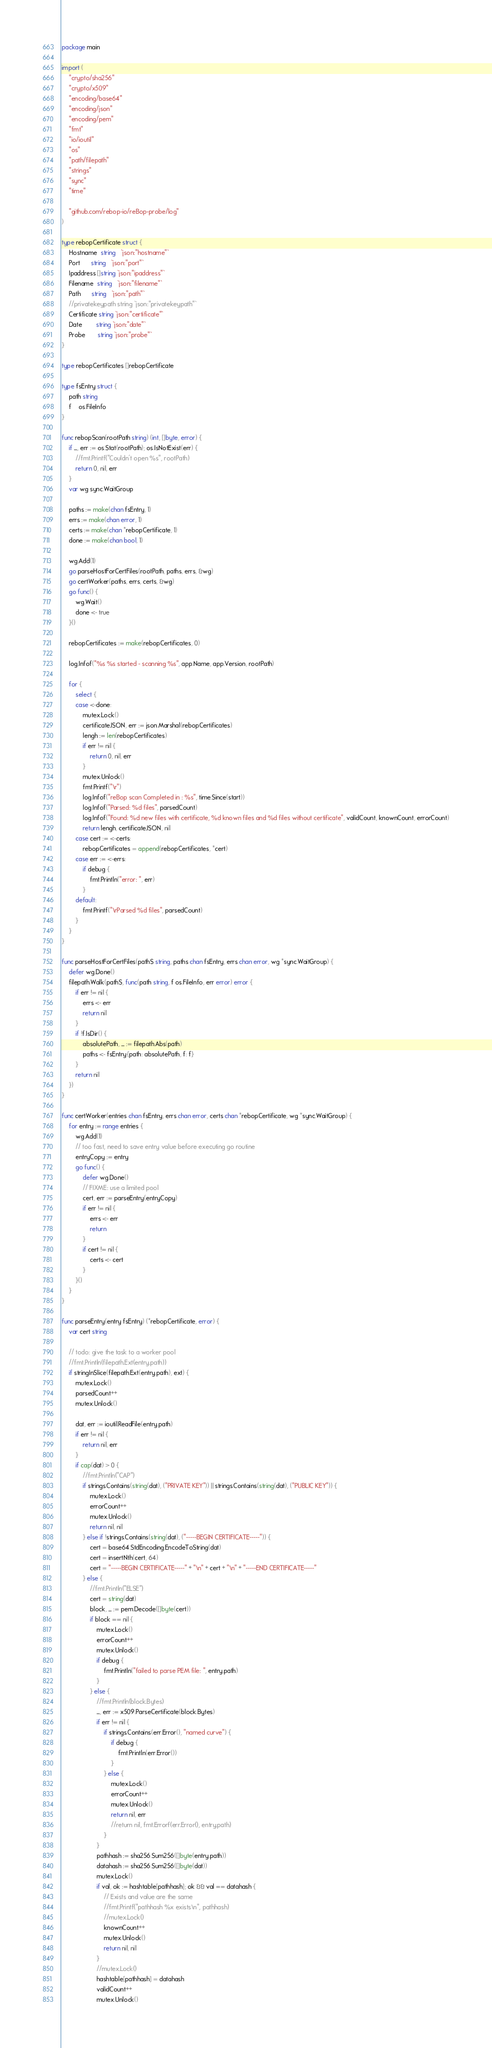<code> <loc_0><loc_0><loc_500><loc_500><_Go_>package main

import (
	"crypto/sha256"
	"crypto/x509"
	"encoding/base64"
	"encoding/json"
	"encoding/pem"
	"fmt"
	"io/ioutil"
	"os"
	"path/filepath"
	"strings"
	"sync"
	"time"

	"github.com/rebop-io/reBop-probe/log"
)

type rebopCertificate struct {
	Hostname  string   `json:"hostname"`
	Port      string   `json:"port"`
	Ipaddress []string `json:"ipaddress"`
	Filename  string   `json:"filename"`
	Path      string   `json:"path"`
	//privatekeypath string `json:"privatekeypath"`
	Certificate string `json:"certificate"`
	Date        string `json:"date"`
	Probe       string `json:"probe"`
}

type rebopCertificates []rebopCertificate

type fsEntry struct {
	path string
	f    os.FileInfo
}

func rebopScan(rootPath string) (int, []byte, error) {
	if _, err := os.Stat(rootPath); os.IsNotExist(err) {
		//fmt.Printf("Couldn't open %s", rootPath)
		return 0, nil, err
	}
	var wg sync.WaitGroup

	paths := make(chan fsEntry, 1)
	errs := make(chan error, 1)
	certs := make(chan *rebopCertificate, 1)
	done := make(chan bool, 1)

	wg.Add(1)
	go parseHostForCertFiles(rootPath, paths, errs, &wg)
	go certWorker(paths, errs, certs, &wg)
	go func() {
		wg.Wait()
		done <- true
	}()

	rebopCertificates := make(rebopCertificates, 0)

	log.Infof("%s %s started - scanning %s", app.Name, app.Version, rootPath)

	for {
		select {
		case <-done:
			mutex.Lock()
			certificateJSON, err := json.Marshal(rebopCertificates)
			lengh := len(rebopCertificates)
			if err != nil {
				return 0, nil, err
			}
			mutex.Unlock()
			fmt.Printf("\r")
			log.Infof("reBop scan Completed in : %s", time.Since(start))
			log.Infof("Parsed: %d files", parsedCount)
			log.Infof("Found: %d new files with certificate, %d known files and %d files without certificate", validCount, knownCount, errorCount)
			return lengh, certificateJSON, nil
		case cert := <-certs:
			rebopCertificates = append(rebopCertificates, *cert)
		case err := <-errs:
			if debug {
				fmt.Println("error: ", err)
			}
		default:
			fmt.Printf("\rParsed %d files", parsedCount)
		}
	}
}

func parseHostForCertFiles(pathS string, paths chan fsEntry, errs chan error, wg *sync.WaitGroup) {
	defer wg.Done()
	filepath.Walk(pathS, func(path string, f os.FileInfo, err error) error {
		if err != nil {
			errs <- err
			return nil
		}
		if !f.IsDir() {
			absolutePath, _ := filepath.Abs(path)
			paths <- fsEntry{path: absolutePath, f: f}
		}
		return nil
	})
}

func certWorker(entries chan fsEntry, errs chan error, certs chan *rebopCertificate, wg *sync.WaitGroup) {
	for entry := range entries {
		wg.Add(1)
		// too fast, need to save entry value before executing go routine
		entryCopy := entry
		go func() {
			defer wg.Done()
			// FIXME: use a limited pool
			cert, err := parseEntry(entryCopy)
			if err != nil {
				errs <- err
				return
			}
			if cert != nil {
				certs <- cert
			}
		}()
	}
}

func parseEntry(entry fsEntry) (*rebopCertificate, error) {
	var cert string

	// todo: give the task to a worker pool
	//fmt.Println(filepath.Ext(entry.path))
	if stringInSlice(filepath.Ext(entry.path), ext) {
		mutex.Lock()
		parsedCount++
		mutex.Unlock()

		dat, err := ioutil.ReadFile(entry.path)
		if err != nil {
			return nil, err
		}
		if cap(dat) > 0 {
			//fmt.Println("CAP")
			if strings.Contains(string(dat), ("PRIVATE KEY")) || strings.Contains(string(dat), ("PUBLIC KEY")) {
				mutex.Lock()
				errorCount++
				mutex.Unlock()
				return nil, nil
			} else if !strings.Contains(string(dat), ("-----BEGIN CERTIFICATE-----")) {
				cert = base64.StdEncoding.EncodeToString(dat)
				cert = insertNth(cert, 64)
				cert = "-----BEGIN CERTIFICATE-----" + "\n" + cert + "\n" + "-----END CERTIFICATE-----"
			} else {
				//fmt.Println("ELSE")
				cert = string(dat)
				block, _ := pem.Decode([]byte(cert))
				if block == nil {
					mutex.Lock()
					errorCount++
					mutex.Unlock()
					if debug {
						fmt.Println("failed to parse PEM file: ", entry.path)
					}
				} else {
					//fmt.Println(block.Bytes)
					_, err := x509.ParseCertificate(block.Bytes)
					if err != nil {
						if strings.Contains(err.Error(), "named curve") {
							if debug {
								fmt.Println(err.Error())
							}
						} else {
							mutex.Lock()
							errorCount++
							mutex.Unlock()
							return nil, err
							//return nil, fmt.Errorf(err.Error(), entry.path)
						}
					}
					pathhash := sha256.Sum256([]byte(entry.path))
					datahash := sha256.Sum256([]byte(dat))
					mutex.Lock()
					if val, ok := hashtable[pathhash]; ok && val == datahash {
						// Exists and value are the same
						//fmt.Printf("pathhash %x exists\n", pathhash)
						//mutex.Lock()
						knownCount++
						mutex.Unlock()
						return nil, nil
					}
					//mutex.Lock()
					hashtable[pathhash] = datahash
					validCount++
					mutex.Unlock()</code> 